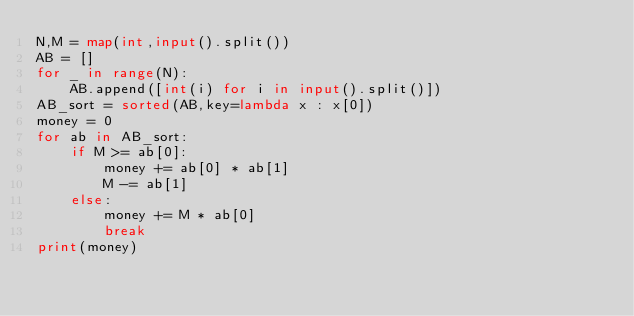<code> <loc_0><loc_0><loc_500><loc_500><_Python_>N,M = map(int,input().split())
AB = []
for _ in range(N):
    AB.append([int(i) for i in input().split()])
AB_sort = sorted(AB,key=lambda x : x[0])
money = 0
for ab in AB_sort:
    if M >= ab[0]:
        money += ab[0] * ab[1]
        M -= ab[1]
    else:
        money += M * ab[0]
        break
print(money)
</code> 